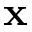Convert formula to latex. <formula><loc_0><loc_0><loc_500><loc_500>\mathbf x</formula> 